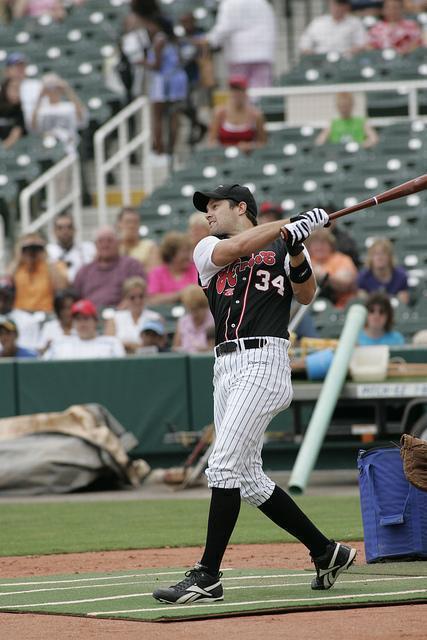Why is the player wearing gloves?
Choose the right answer from the provided options to respond to the question.
Options: Warmth, grip, fashion, health. Grip. 